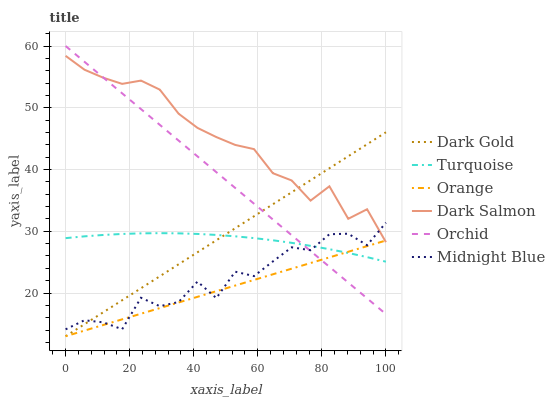Does Orange have the minimum area under the curve?
Answer yes or no. Yes. Does Dark Salmon have the maximum area under the curve?
Answer yes or no. Yes. Does Midnight Blue have the minimum area under the curve?
Answer yes or no. No. Does Midnight Blue have the maximum area under the curve?
Answer yes or no. No. Is Dark Gold the smoothest?
Answer yes or no. Yes. Is Midnight Blue the roughest?
Answer yes or no. Yes. Is Midnight Blue the smoothest?
Answer yes or no. No. Is Dark Gold the roughest?
Answer yes or no. No. Does Midnight Blue have the lowest value?
Answer yes or no. No. Does Orchid have the highest value?
Answer yes or no. Yes. Does Midnight Blue have the highest value?
Answer yes or no. No. Is Turquoise less than Dark Salmon?
Answer yes or no. Yes. Is Dark Salmon greater than Turquoise?
Answer yes or no. Yes. Does Orange intersect Dark Salmon?
Answer yes or no. Yes. Is Orange less than Dark Salmon?
Answer yes or no. No. Is Orange greater than Dark Salmon?
Answer yes or no. No. Does Turquoise intersect Dark Salmon?
Answer yes or no. No. 